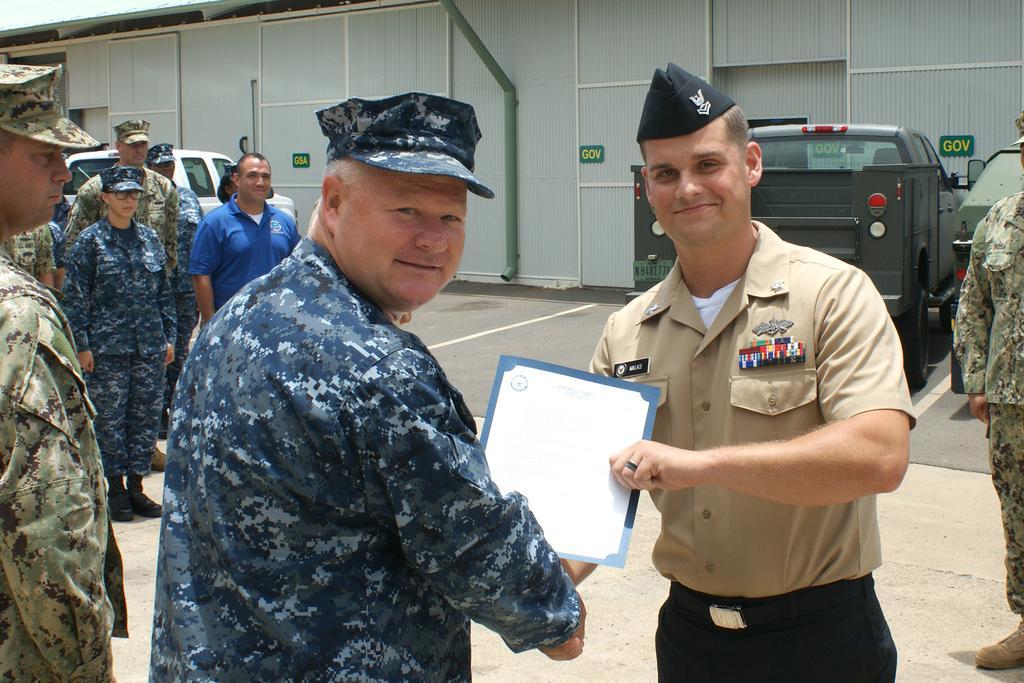Please provide a concise description of this image. Here we can see a group of people. These two people are giving shake-hand and smiling. This man is holding a card. Background there is a shed and vehicles. 